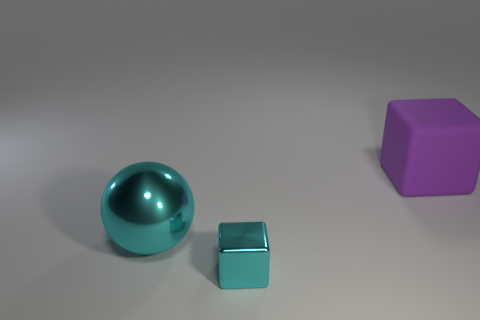Is there anything else that is the same size as the shiny block?
Offer a terse response. No. Are there any other things that are made of the same material as the large purple object?
Ensure brevity in your answer.  No. What size is the thing that is both in front of the large matte cube and right of the big metallic object?
Ensure brevity in your answer.  Small. How many big balls have the same material as the purple block?
Provide a short and direct response. 0. There is a cube that is in front of the large ball; what number of big cyan spheres are in front of it?
Offer a very short reply. 0. What shape is the large thing on the left side of the metal object to the right of the big thing that is left of the large matte object?
Make the answer very short. Sphere. What size is the cube that is the same color as the metallic sphere?
Provide a short and direct response. Small. How many objects are either large rubber cubes or gray rubber things?
Make the answer very short. 1. What color is the sphere that is the same size as the purple rubber object?
Make the answer very short. Cyan. Does the tiny cyan object have the same shape as the thing right of the shiny block?
Provide a short and direct response. Yes. 